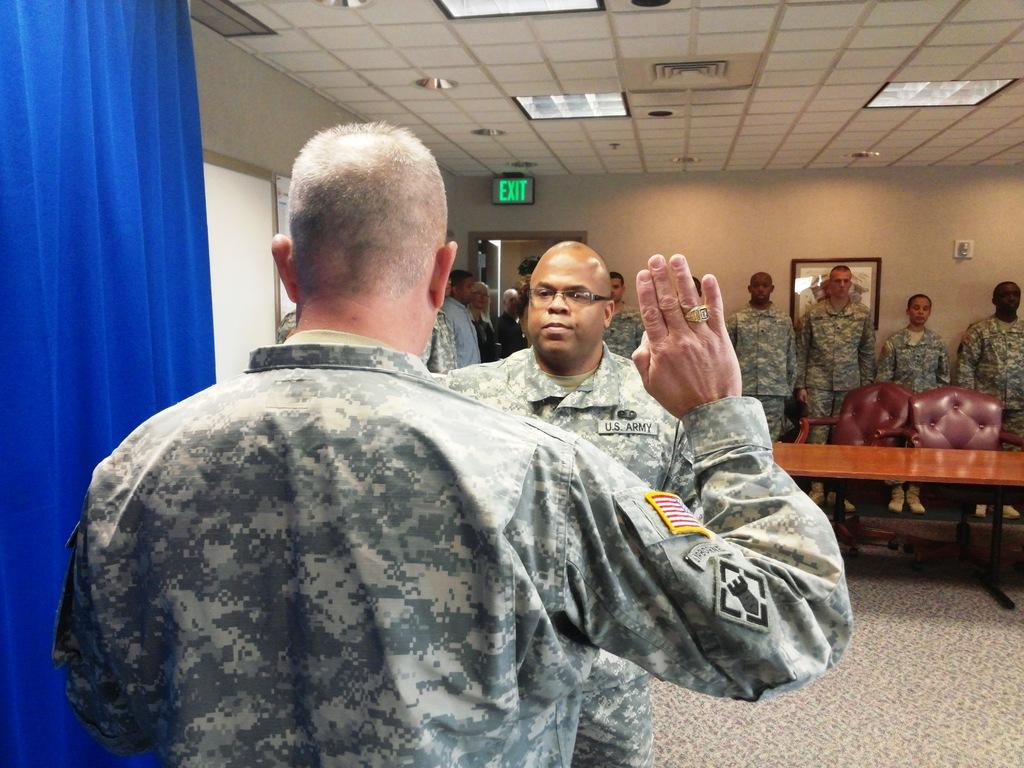What is the main subject of the image? The main subject of the image is a group of persons standing in the center. Can you describe any objects or features in the image? Yes, there is a curtain, a table, and a chair visible in the image. What can be seen in the background of the image? There is a wall visible in the background of the image. How many ladybugs are crawling on the table in the image? There are no ladybugs present in the image; the table is empty except for the chair. 